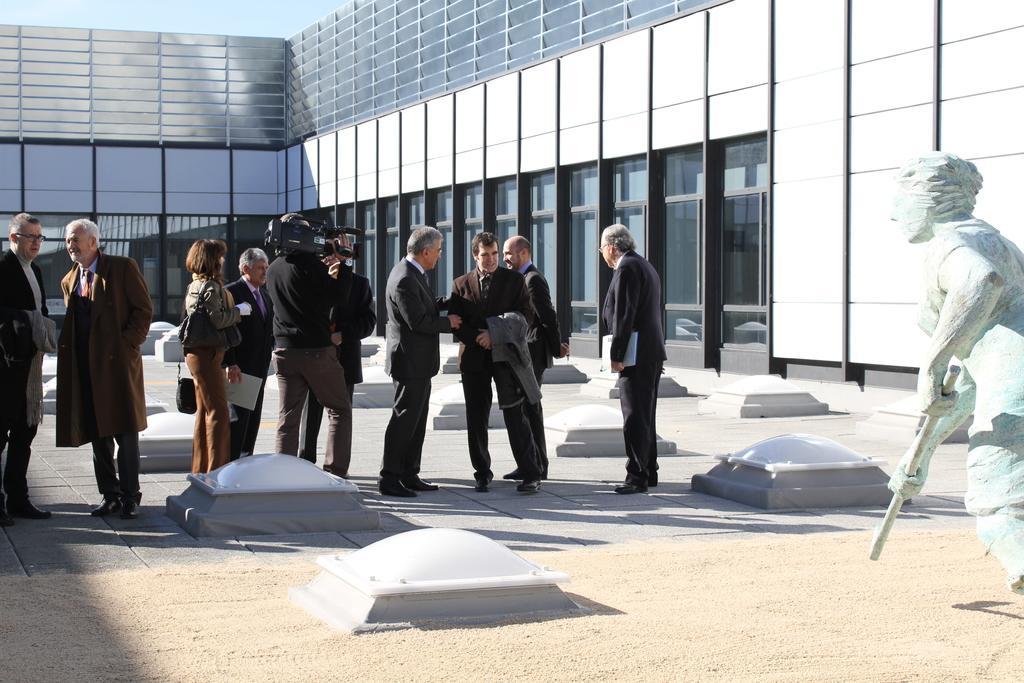In one or two sentences, can you explain what this image depicts? In this image we can see people standing. At the bottom there are barriers. On the right we can see a statue. At the bottom there is sand. In the background there is a building and sky. 